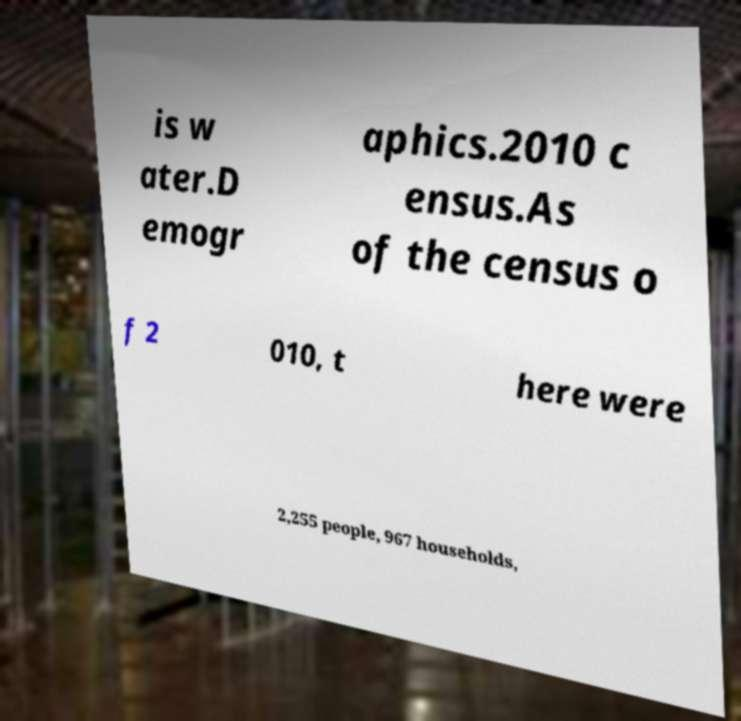Please identify and transcribe the text found in this image. is w ater.D emogr aphics.2010 c ensus.As of the census o f 2 010, t here were 2,255 people, 967 households, 